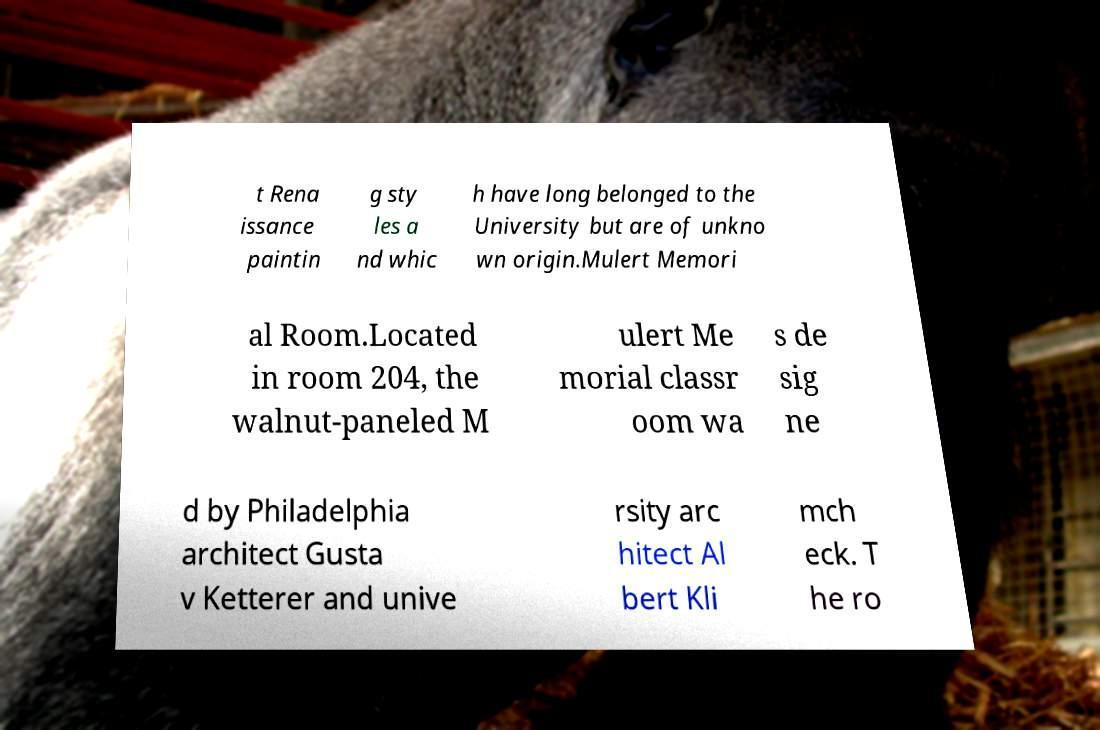Could you extract and type out the text from this image? t Rena issance paintin g sty les a nd whic h have long belonged to the University but are of unkno wn origin.Mulert Memori al Room.Located in room 204, the walnut-paneled M ulert Me morial classr oom wa s de sig ne d by Philadelphia architect Gusta v Ketterer and unive rsity arc hitect Al bert Kli mch eck. T he ro 